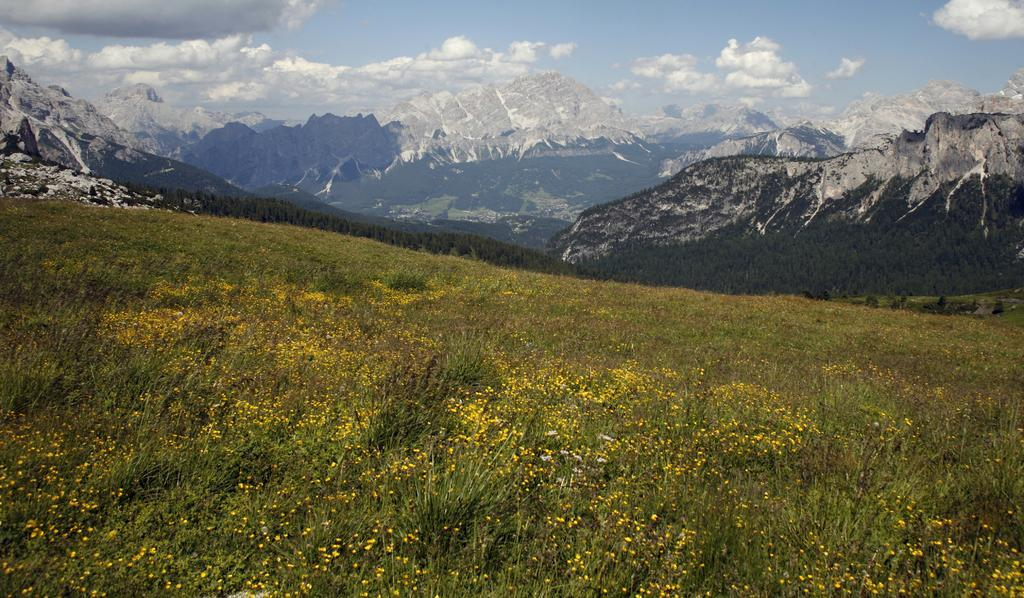What types of vegetation are at the bottom of the image? There are plants and flowers at the bottom of the image. What can be seen in the distance in the image? Hills are visible in the background of the image. How would you describe the sky in the image? The sky is cloudy in the background of the image. What else is present in the middle of the image besides the hills? There are trees in the middle of the image. Where is the hospital located in the image? There is no hospital present in the image. What type of test is being conducted on the plants in the image? There is no test being conducted on the plants in the image; they are simply depicted as part of the landscape. 